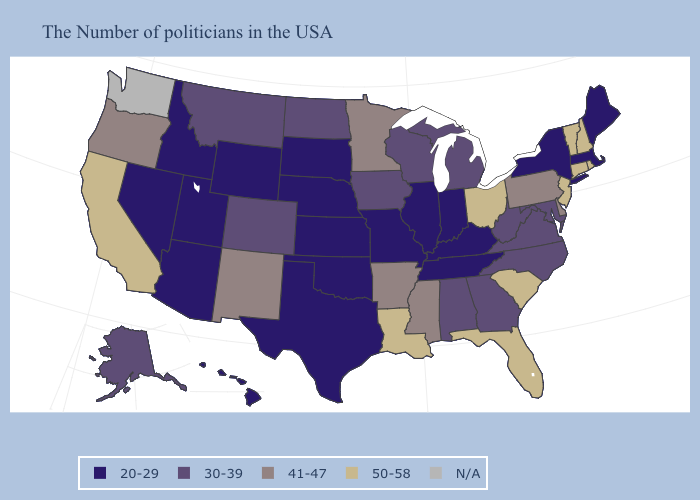What is the highest value in the Northeast ?
Give a very brief answer. 50-58. Does the first symbol in the legend represent the smallest category?
Quick response, please. Yes. What is the lowest value in the South?
Be succinct. 20-29. Does the first symbol in the legend represent the smallest category?
Short answer required. Yes. What is the value of North Dakota?
Answer briefly. 30-39. Does Montana have the lowest value in the West?
Short answer required. No. Name the states that have a value in the range 20-29?
Answer briefly. Maine, Massachusetts, New York, Kentucky, Indiana, Tennessee, Illinois, Missouri, Kansas, Nebraska, Oklahoma, Texas, South Dakota, Wyoming, Utah, Arizona, Idaho, Nevada, Hawaii. Name the states that have a value in the range 41-47?
Keep it brief. Delaware, Pennsylvania, Mississippi, Arkansas, Minnesota, New Mexico, Oregon. Which states hav the highest value in the Northeast?
Short answer required. Rhode Island, New Hampshire, Vermont, Connecticut, New Jersey. Does Alabama have the lowest value in the USA?
Short answer required. No. Among the states that border Maryland , which have the highest value?
Give a very brief answer. Delaware, Pennsylvania. What is the value of Montana?
Be succinct. 30-39. Does the map have missing data?
Quick response, please. Yes. 